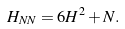<formula> <loc_0><loc_0><loc_500><loc_500>H _ { N N } = 6 H ^ { 2 } + N .</formula> 